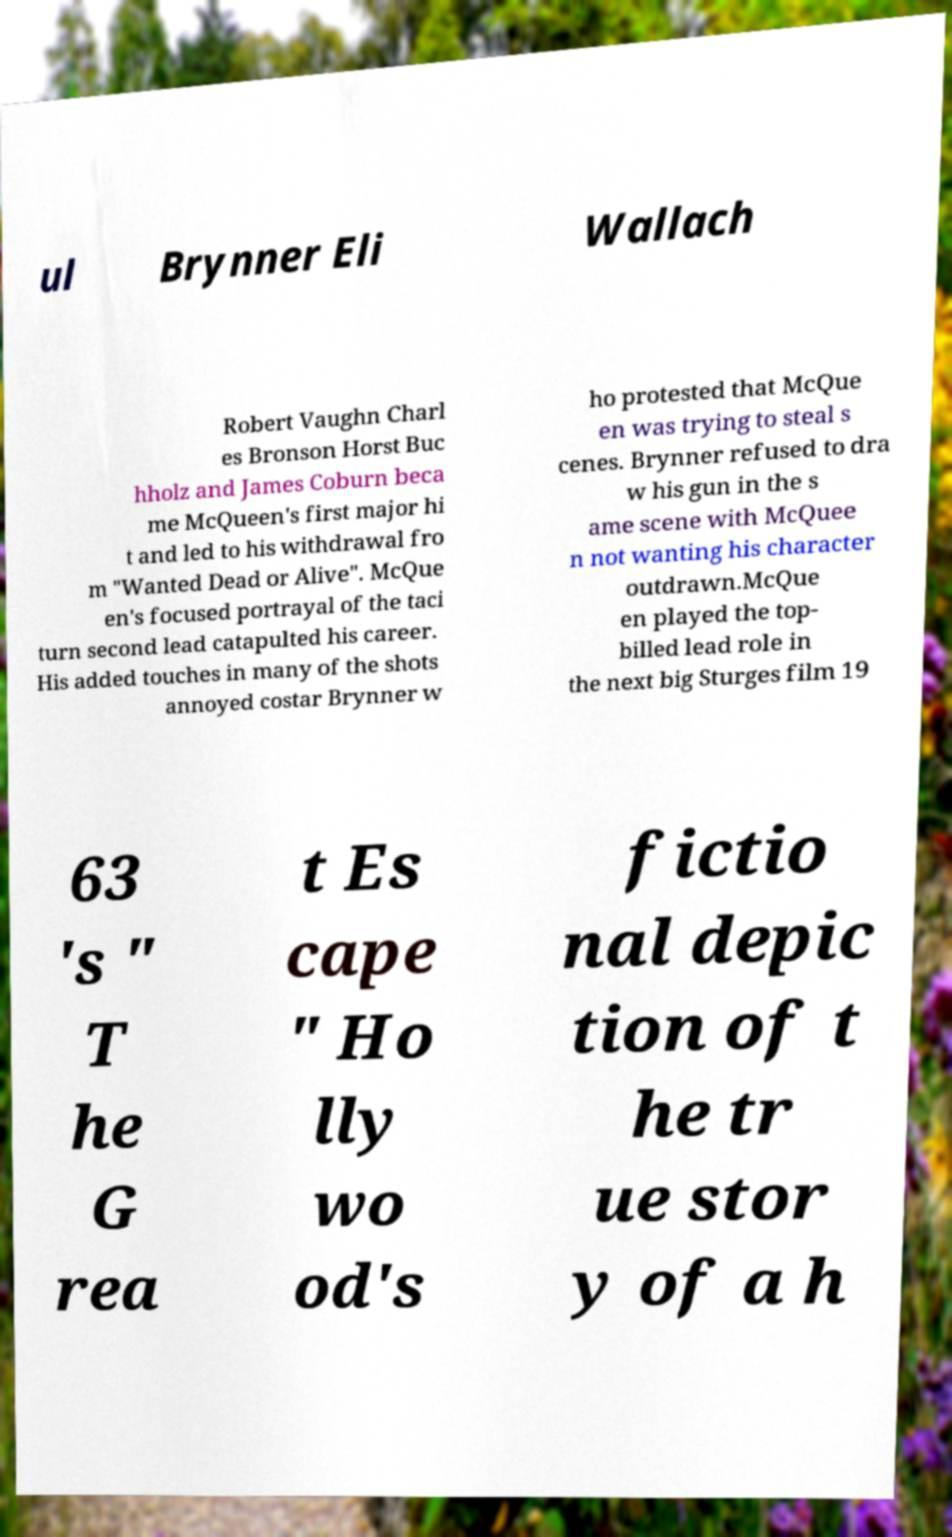Can you read and provide the text displayed in the image?This photo seems to have some interesting text. Can you extract and type it out for me? ul Brynner Eli Wallach Robert Vaughn Charl es Bronson Horst Buc hholz and James Coburn beca me McQueen's first major hi t and led to his withdrawal fro m "Wanted Dead or Alive". McQue en's focused portrayal of the taci turn second lead catapulted his career. His added touches in many of the shots annoyed costar Brynner w ho protested that McQue en was trying to steal s cenes. Brynner refused to dra w his gun in the s ame scene with McQuee n not wanting his character outdrawn.McQue en played the top- billed lead role in the next big Sturges film 19 63 's " T he G rea t Es cape " Ho lly wo od's fictio nal depic tion of t he tr ue stor y of a h 